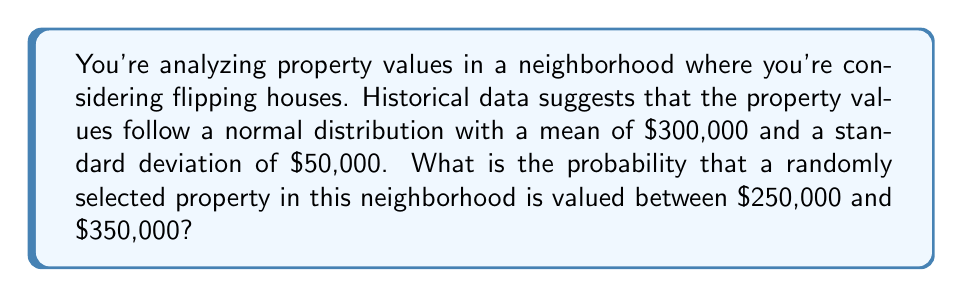Solve this math problem. Let's approach this step-by-step:

1) We're dealing with a normal distribution where:
   $\mu = 300,000$ (mean)
   $\sigma = 50,000$ (standard deviation)

2) We need to find $P(250,000 < X < 350,000)$

3) To use the standard normal distribution, we need to standardize these values:
   
   $z = \frac{x - \mu}{\sigma}$

4) For the lower bound: $z_1 = \frac{250,000 - 300,000}{50,000} = -1$
   For the upper bound: $z_2 = \frac{350,000 - 300,000}{50,000} = 1$

5) Now we need to find $P(-1 < Z < 1)$

6) Using the standard normal distribution table or calculator:
   $P(Z < 1) = 0.8413$
   $P(Z < -1) = 0.1587$

7) Therefore, $P(-1 < Z < 1) = 0.8413 - 0.1587 = 0.6826$

This means there's a 68.26% chance that a randomly selected property in this neighborhood is valued between $250,000 and $350,000.
Answer: 0.6826 or 68.26% 